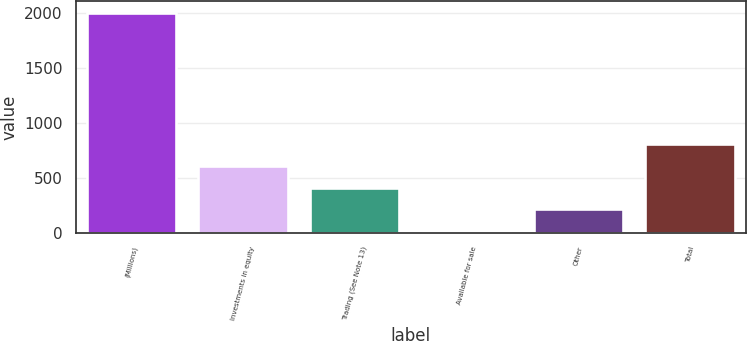<chart> <loc_0><loc_0><loc_500><loc_500><bar_chart><fcel>(Millions)<fcel>Investments in equity<fcel>Trading (See Note 13)<fcel>Available for sale<fcel>Other<fcel>Total<nl><fcel>2006<fcel>610.9<fcel>411.6<fcel>13<fcel>212.3<fcel>810.2<nl></chart> 